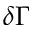<formula> <loc_0><loc_0><loc_500><loc_500>\delta \Gamma</formula> 